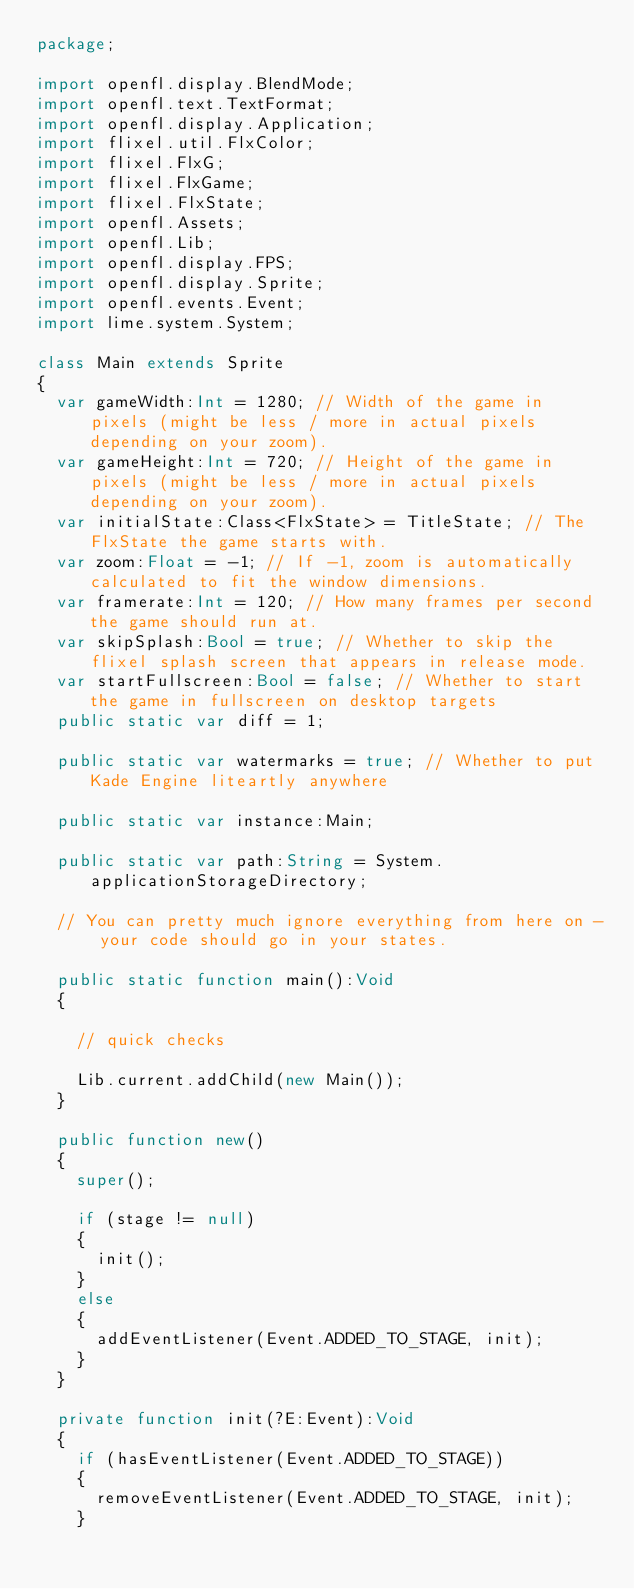<code> <loc_0><loc_0><loc_500><loc_500><_Haxe_>package;

import openfl.display.BlendMode;
import openfl.text.TextFormat;
import openfl.display.Application;
import flixel.util.FlxColor;
import flixel.FlxG;
import flixel.FlxGame;
import flixel.FlxState;
import openfl.Assets;
import openfl.Lib;
import openfl.display.FPS;
import openfl.display.Sprite;
import openfl.events.Event;
import lime.system.System;

class Main extends Sprite
{
	var gameWidth:Int = 1280; // Width of the game in pixels (might be less / more in actual pixels depending on your zoom).
	var gameHeight:Int = 720; // Height of the game in pixels (might be less / more in actual pixels depending on your zoom).
	var initialState:Class<FlxState> = TitleState; // The FlxState the game starts with.
	var zoom:Float = -1; // If -1, zoom is automatically calculated to fit the window dimensions.
	var framerate:Int = 120; // How many frames per second the game should run at.
	var skipSplash:Bool = true; // Whether to skip the flixel splash screen that appears in release mode.
	var startFullscreen:Bool = false; // Whether to start the game in fullscreen on desktop targets
	public static var diff = 1;

	public static var watermarks = true; // Whether to put Kade Engine liteartly anywhere

	public static var instance:Main;

	public static var path:String = System.applicationStorageDirectory;

	// You can pretty much ignore everything from here on - your code should go in your states.

	public static function main():Void
	{

		// quick checks 

		Lib.current.addChild(new Main());
	}

	public function new()
	{
		super();

		if (stage != null)
		{
			init();
		}
		else
		{
			addEventListener(Event.ADDED_TO_STAGE, init);
		}
	}

	private function init(?E:Event):Void
	{
		if (hasEventListener(Event.ADDED_TO_STAGE))
		{
			removeEventListener(Event.ADDED_TO_STAGE, init);
		}
</code> 